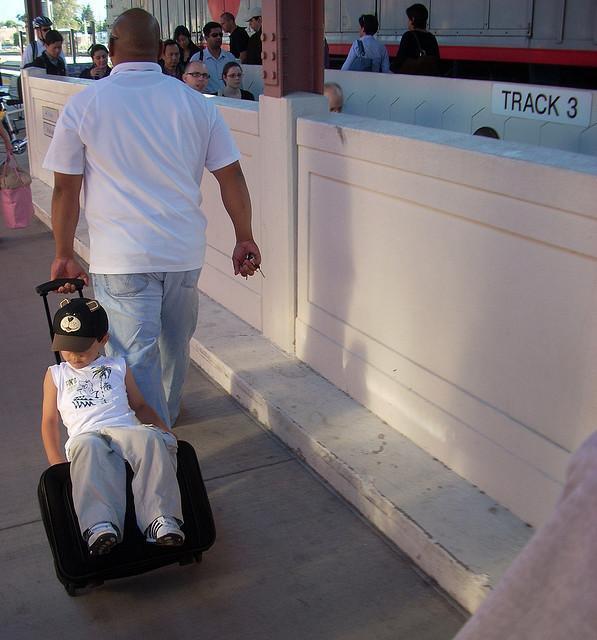How many people can be seen?
Give a very brief answer. 4. 